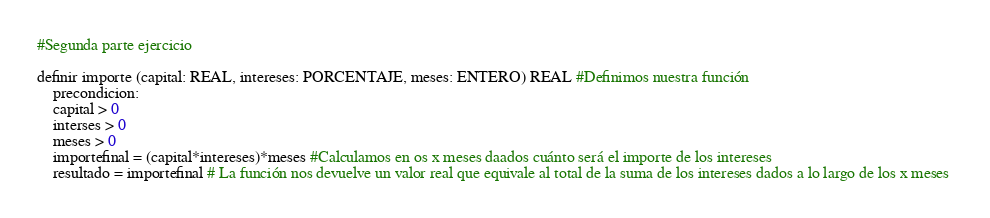Convert code to text. <code><loc_0><loc_0><loc_500><loc_500><_Python_>
#Segunda parte ejercicio

definir importe (capital: REAL, intereses: PORCENTAJE, meses: ENTERO) REAL #Definimos nuestra función
    precondicion:
    capital > 0
    interses > 0
    meses > 0
    importefinal = (capital*intereses)*meses #Calculamos en os x meses daados cuánto será el importe de los intereses
    resultado = importefinal # La función nos devuelve un valor real que equivale al total de la suma de los intereses dados a lo largo de los x meses </code> 